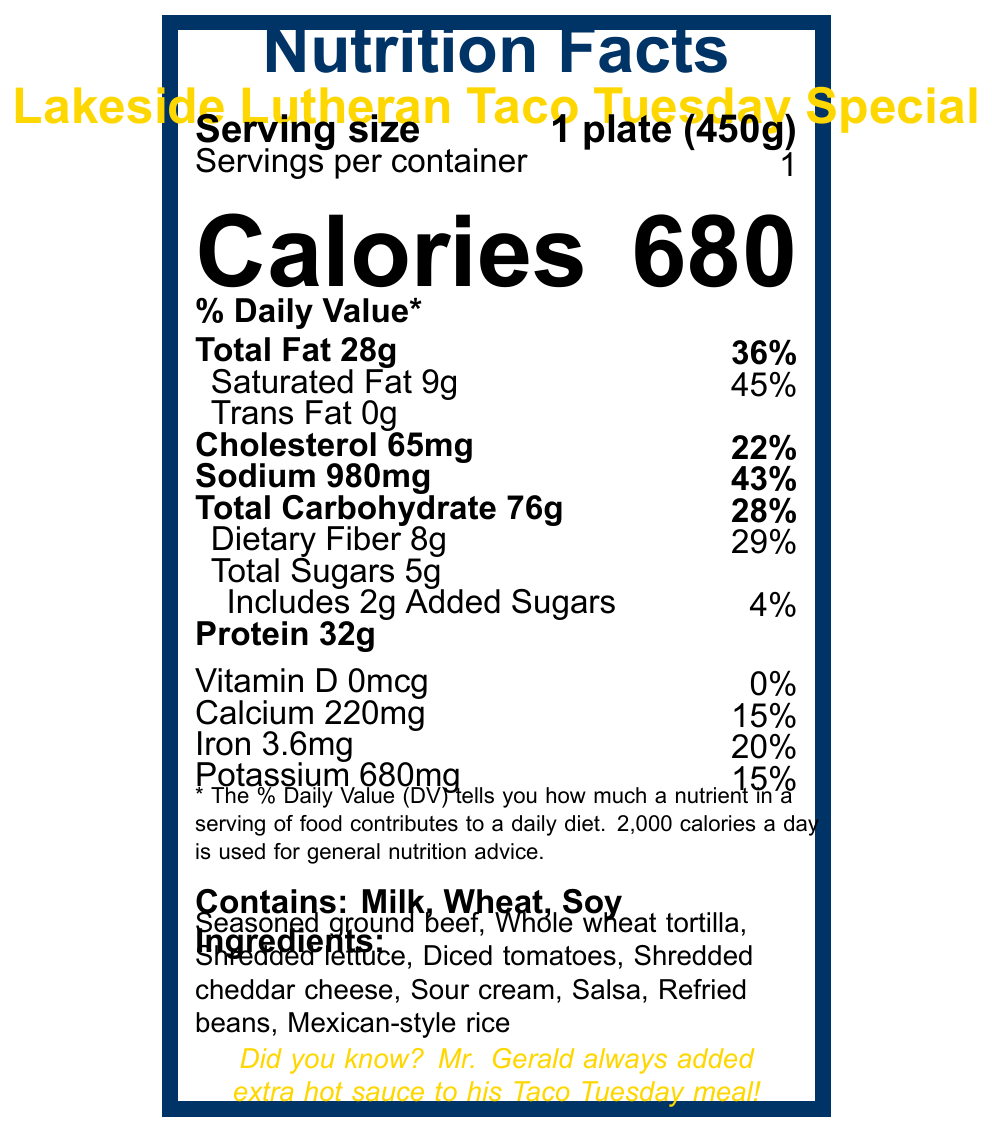what is the serving size of the meal? The document lists the serving size as "1 plate (450g)" near the top.
Answer: 1 plate (450g) how much sodium does the meal contain? The document specifies the sodium content as 980mg in the nutrition facts section.
Answer: 980mg What percentage of the daily value does dietary fiber contribute? The nutrition facts section states that dietary fiber contributes 29% of the daily value.
Answer: 29% What is the total fat content in the meal? The document shows that the total fat content is 28g.
Answer: 28g What allergens are present in this meal? The document lists the allergens as "Milk, Wheat, Soy" under the allergens section.
Answer: Milk, Wheat, Soy how many grams of protein are in the meal? The nutrition facts section states that the protein content is 32g.
Answer: 32g what is the source of the tomatoes used in the meal? The additional info section mentions that the tomatoes come from Lakeside Lutheran’s garden.
Answer: Lakeside Lutheran’s garden How many grams of saturated fat does the meal contain? The document specifies that the meal contains 9g of saturated fat.
Answer: 9g What is the calorie count of the meal? The document prominently displays that the meal contains 680 calories near the top.
Answer: 680 Which of the following ingredients is found in the meal? A. Chicken B. Beef C. Pork D. Fish The document lists "Seasoned ground beef" in the ingredients section.
Answer: B Who prepared the meal? A. Chef Maria Rodriguez B. Chef John Smith C. Chef Emily Brown D. Chef Michael Lee The additional info section states that the meal was prepared by Chef Maria Rodriguez.
Answer: A Is there any trans fat in this meal? The document states that the trans fat amount is 0g.
Answer: No What does this document describe? The document outlines the nutritional content, ingredients, allergens, and special notes about the Taco Tuesday Special meal served at Lakeside Lutheran High School’s cafeteria. It includes details about portion size, macronutrients, micronutrients, who prepared and approved the meal, and some fun facts.
Answer: This document provides the nutrition facts, ingredients, allergens, and additional information about the Lakeside Lutheran Taco Tuesday Special meal. What is the percentage daily value for calcium in the meal? The nutrition facts section states that calcium contributes 15% of the daily value.
Answer: 15% What’s the approval status of the meal and who approved it? The document does state that it was approved by a nutritionist named Sarah Johnson, but it doesn't elaborate on the approval process or status.
Answer: Not enough information 